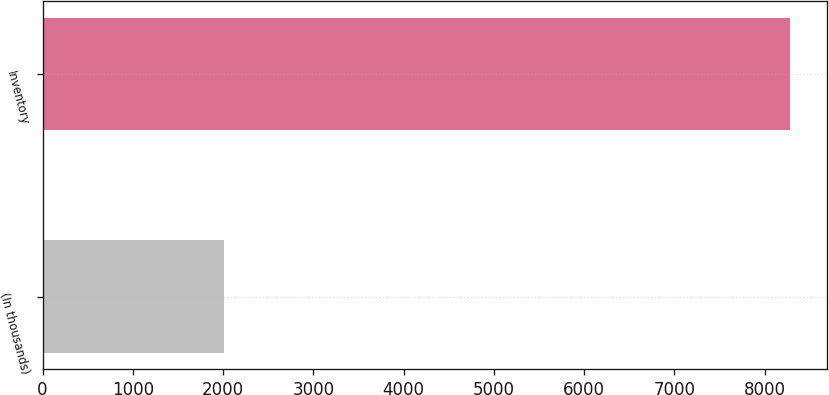<chart> <loc_0><loc_0><loc_500><loc_500><bar_chart><fcel>(In thousands)<fcel>Inventory<nl><fcel>2014<fcel>8278<nl></chart> 